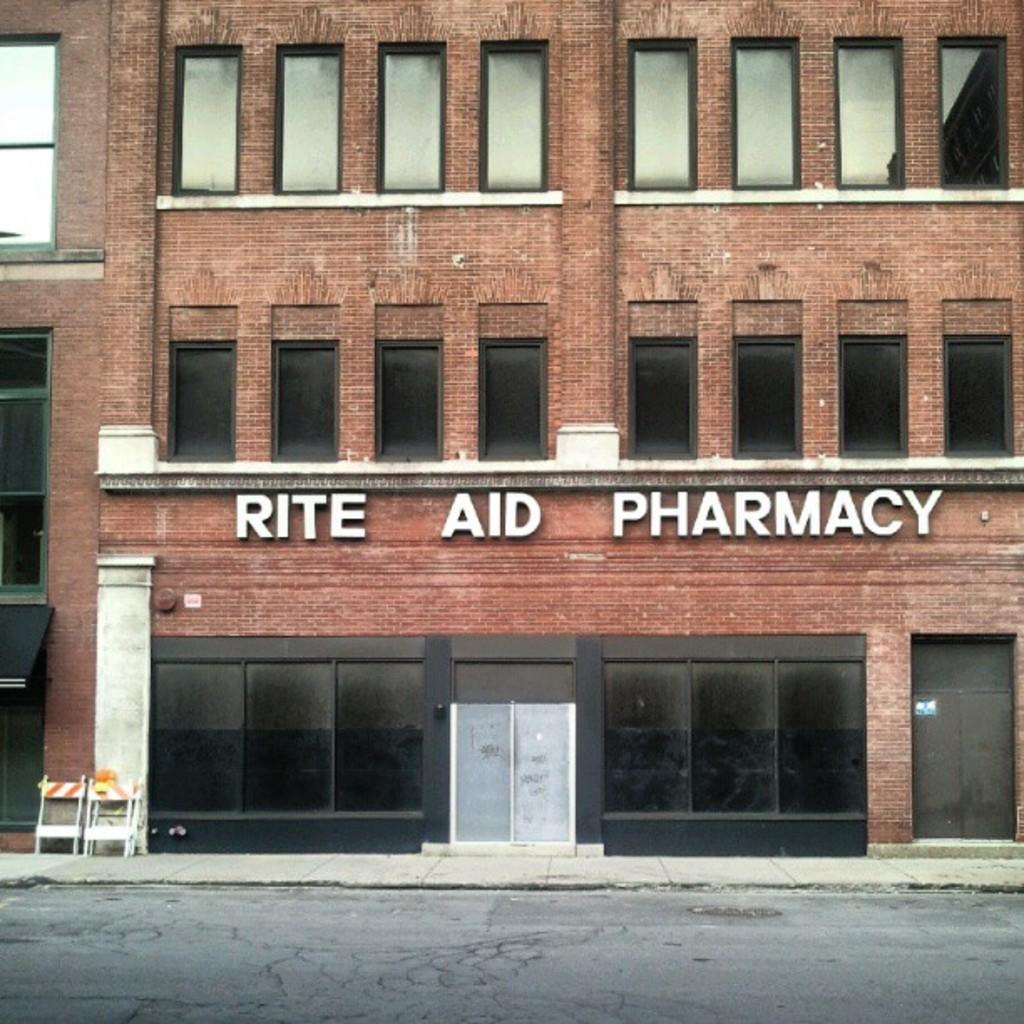Please provide a concise description of this image. In this image, I can see a building with a name board and glass windows. At the bottom of the image, there is a road. At the bottom left side of the image, I can see the barricades. 